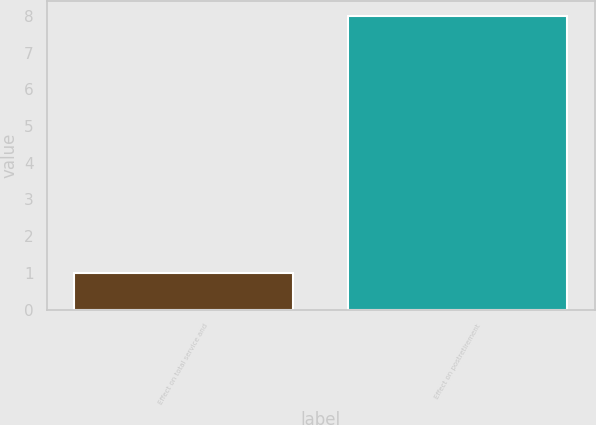Convert chart. <chart><loc_0><loc_0><loc_500><loc_500><bar_chart><fcel>Effect on total service and<fcel>Effect on postretirement<nl><fcel>1<fcel>8<nl></chart> 